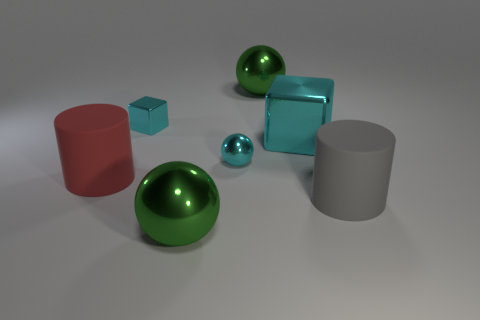How would you describe the arrangement and composition of the shapes in the image? The shapes in the image are arranged in a way that suggests balance and variation; it includes a combination of geometric solids like spheres, cylinders, and cubes, characterized by different sizes and colors. The composition is carefully staged with equal spacing and clean lines that create a harmonious and aesthetically pleasing scene. 